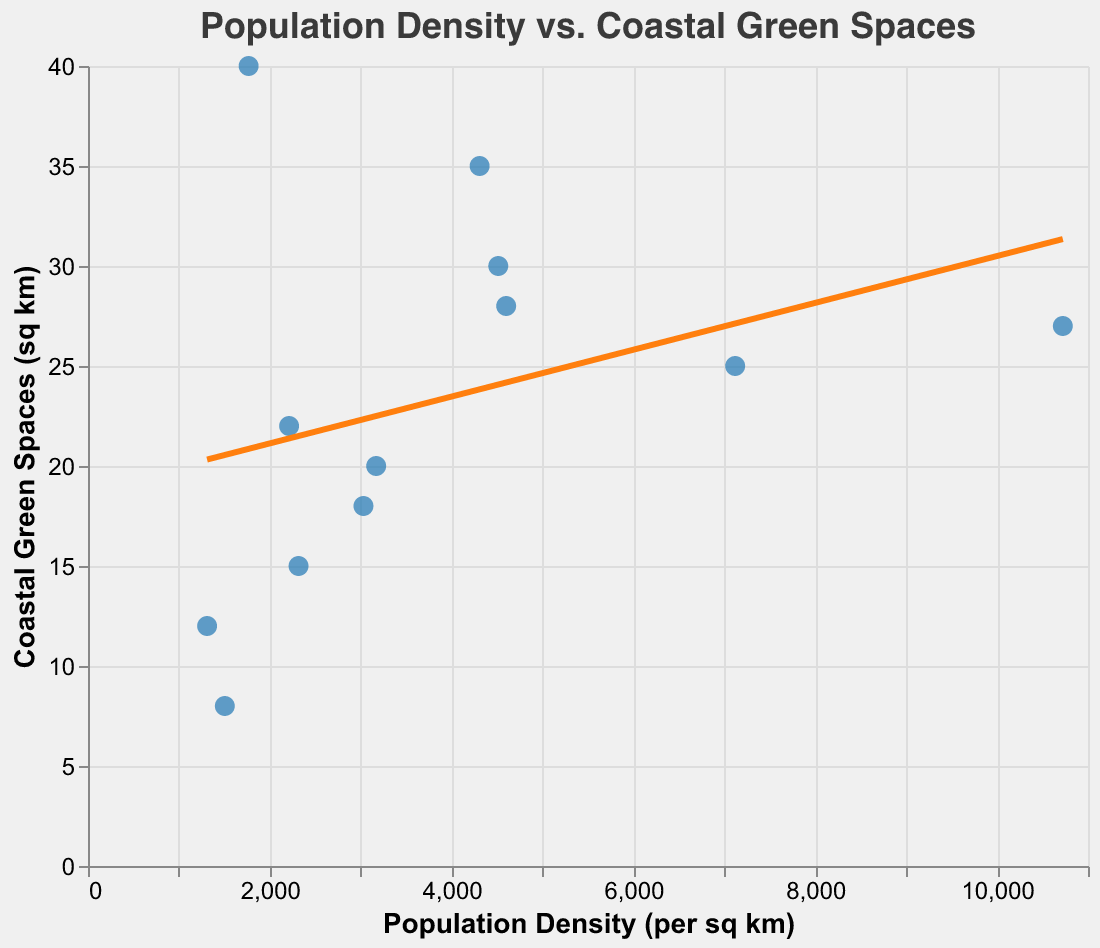What is the title of the scatter plot? The title is displayed at the top of the figure in bold text.
Answer: Population Density vs. Coastal Green Spaces How many data points are shown in the scatter plot? There is one point for each city, and there are 12 cities listed in the data table.
Answer: 12 Which city has the highest population density? The point representing New York City is the farthest to the right on the x-axis, which indicates the highest population density.
Answer: New York City Which city has the most coastal green spaces? Virginia Beach has the highest value on the y-axis, indicating the most coastal green spaces.
Answer: Virginia Beach What color is used for the trend line in the scatter plot? The trend line is orange in the figure.
Answer: Orange Is there a city that stands out as having both high population density and substantial coastal green spaces? San Diego is located fairly high on the y-axis and to the right on the x-axis, indicating both higher population density and substantial coastal green spaces.
Answer: San Diego How does the population density of Seattle compare to that of Boston? Seattle has a population density of 3030 per sq km, which is higher than Boston's 2212 per sq km, visible as Seattle's point is to the right of Boston's point on the x-axis.
Answer: Higher What is the trend depicted by the regression line in the scatter plot? The trend line shows a slight upward slope, indicating that as population density increases, the availability of coastal green spaces increases as well.
Answer: Positive correlation Which city has a similar amount of coastal green spaces as New York City? Miami has a similar y-value to New York City, indicating a similar amount of coastal green spaces (30 sq km for Miami and 27 sq km for New York City).
Answer: Miami 